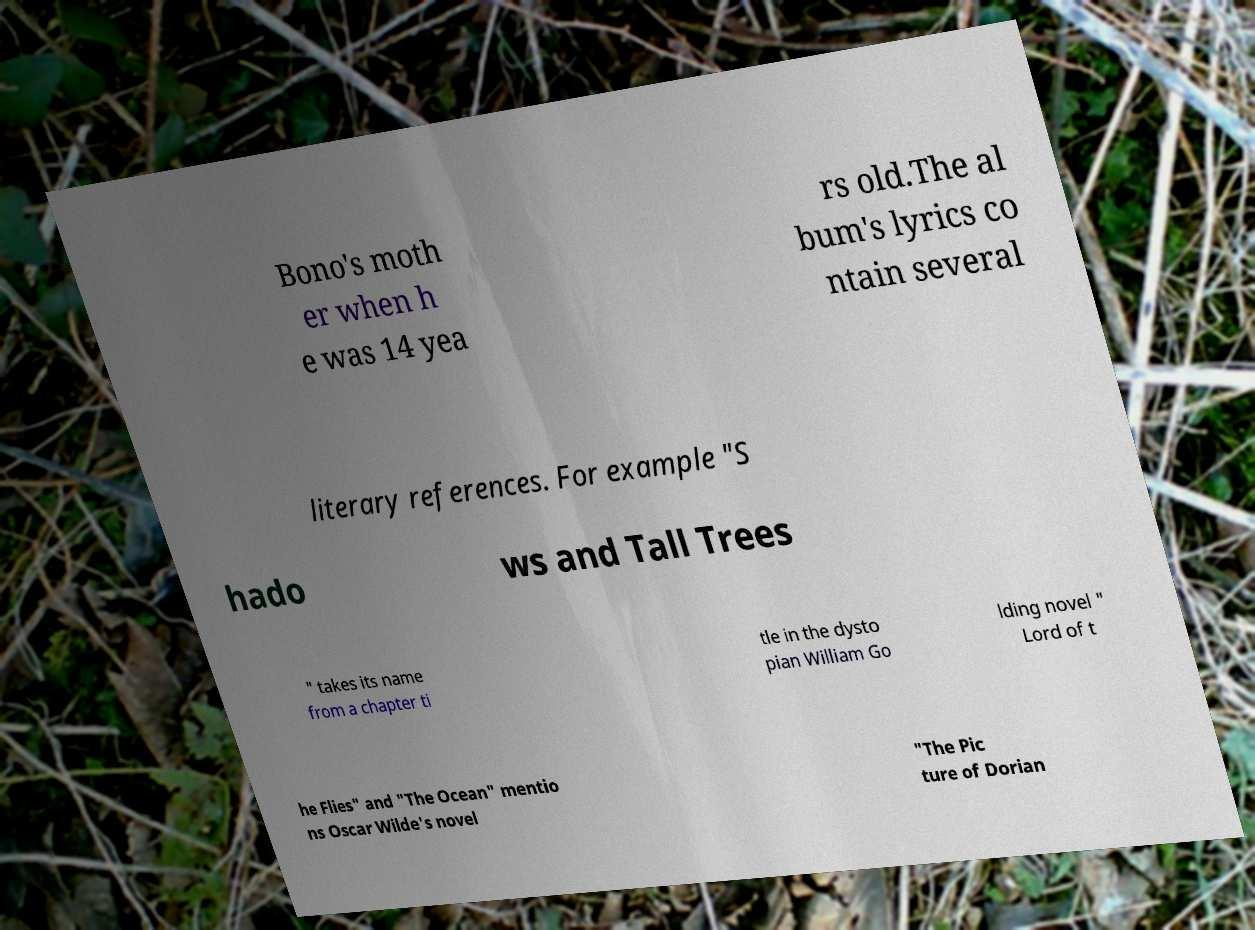There's text embedded in this image that I need extracted. Can you transcribe it verbatim? Bono's moth er when h e was 14 yea rs old.The al bum's lyrics co ntain several literary references. For example "S hado ws and Tall Trees " takes its name from a chapter ti tle in the dysto pian William Go lding novel " Lord of t he Flies" and "The Ocean" mentio ns Oscar Wilde's novel "The Pic ture of Dorian 